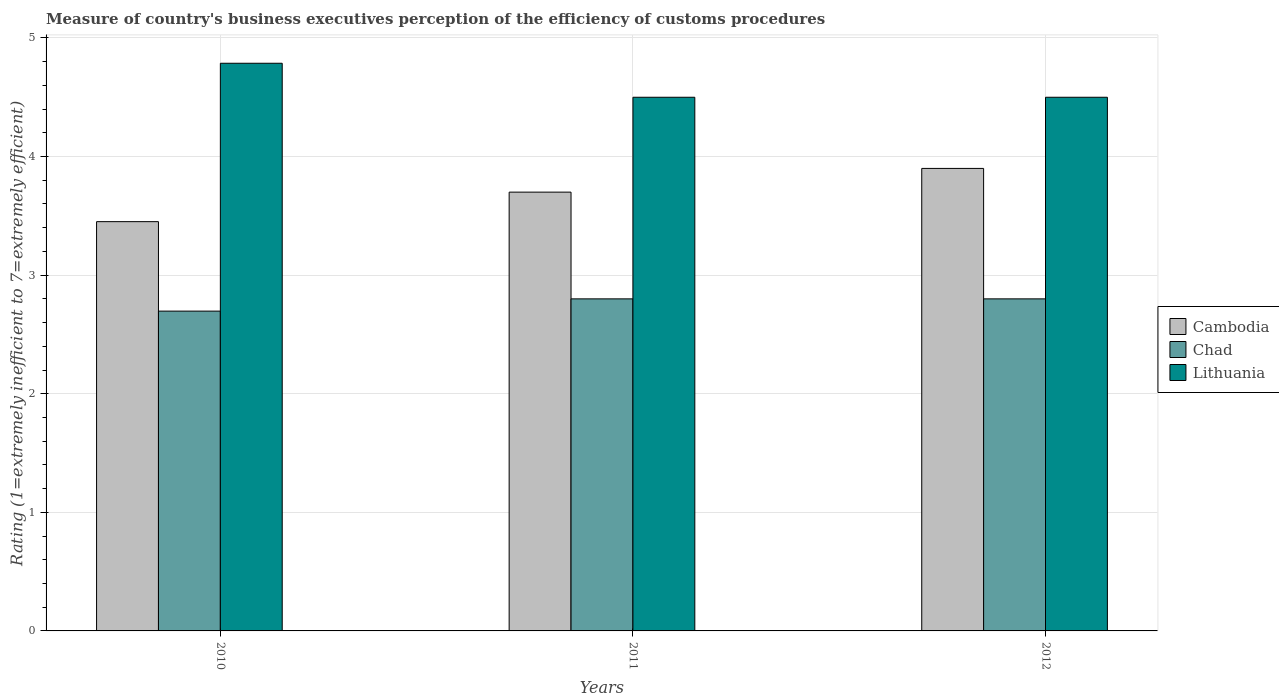How many groups of bars are there?
Offer a very short reply. 3. Are the number of bars per tick equal to the number of legend labels?
Offer a terse response. Yes. How many bars are there on the 3rd tick from the right?
Your response must be concise. 3. In how many cases, is the number of bars for a given year not equal to the number of legend labels?
Your answer should be compact. 0. What is the rating of the efficiency of customs procedure in Cambodia in 2010?
Offer a very short reply. 3.45. Across all years, what is the maximum rating of the efficiency of customs procedure in Chad?
Your response must be concise. 2.8. Across all years, what is the minimum rating of the efficiency of customs procedure in Chad?
Your answer should be compact. 2.7. In which year was the rating of the efficiency of customs procedure in Cambodia minimum?
Give a very brief answer. 2010. What is the total rating of the efficiency of customs procedure in Chad in the graph?
Provide a succinct answer. 8.3. What is the difference between the rating of the efficiency of customs procedure in Cambodia in 2010 and that in 2011?
Your answer should be compact. -0.25. What is the difference between the rating of the efficiency of customs procedure in Lithuania in 2011 and the rating of the efficiency of customs procedure in Chad in 2010?
Ensure brevity in your answer.  1.8. What is the average rating of the efficiency of customs procedure in Chad per year?
Your answer should be very brief. 2.77. In the year 2010, what is the difference between the rating of the efficiency of customs procedure in Cambodia and rating of the efficiency of customs procedure in Lithuania?
Provide a succinct answer. -1.34. What is the ratio of the rating of the efficiency of customs procedure in Cambodia in 2010 to that in 2011?
Provide a short and direct response. 0.93. What is the difference between the highest and the second highest rating of the efficiency of customs procedure in Lithuania?
Offer a terse response. 0.29. What is the difference between the highest and the lowest rating of the efficiency of customs procedure in Cambodia?
Keep it short and to the point. 0.45. In how many years, is the rating of the efficiency of customs procedure in Chad greater than the average rating of the efficiency of customs procedure in Chad taken over all years?
Your response must be concise. 2. What does the 3rd bar from the left in 2011 represents?
Your answer should be compact. Lithuania. What does the 1st bar from the right in 2010 represents?
Offer a terse response. Lithuania. What is the difference between two consecutive major ticks on the Y-axis?
Offer a terse response. 1. Are the values on the major ticks of Y-axis written in scientific E-notation?
Your answer should be compact. No. Where does the legend appear in the graph?
Offer a terse response. Center right. How many legend labels are there?
Ensure brevity in your answer.  3. How are the legend labels stacked?
Ensure brevity in your answer.  Vertical. What is the title of the graph?
Make the answer very short. Measure of country's business executives perception of the efficiency of customs procedures. What is the label or title of the Y-axis?
Provide a short and direct response. Rating (1=extremely inefficient to 7=extremely efficient). What is the Rating (1=extremely inefficient to 7=extremely efficient) in Cambodia in 2010?
Your response must be concise. 3.45. What is the Rating (1=extremely inefficient to 7=extremely efficient) in Chad in 2010?
Make the answer very short. 2.7. What is the Rating (1=extremely inefficient to 7=extremely efficient) of Lithuania in 2010?
Make the answer very short. 4.79. What is the Rating (1=extremely inefficient to 7=extremely efficient) in Cambodia in 2011?
Ensure brevity in your answer.  3.7. What is the Rating (1=extremely inefficient to 7=extremely efficient) in Chad in 2011?
Your answer should be very brief. 2.8. What is the Rating (1=extremely inefficient to 7=extremely efficient) of Lithuania in 2011?
Your response must be concise. 4.5. What is the Rating (1=extremely inefficient to 7=extremely efficient) in Lithuania in 2012?
Your response must be concise. 4.5. Across all years, what is the maximum Rating (1=extremely inefficient to 7=extremely efficient) of Chad?
Make the answer very short. 2.8. Across all years, what is the maximum Rating (1=extremely inefficient to 7=extremely efficient) in Lithuania?
Offer a very short reply. 4.79. Across all years, what is the minimum Rating (1=extremely inefficient to 7=extremely efficient) of Cambodia?
Offer a very short reply. 3.45. Across all years, what is the minimum Rating (1=extremely inefficient to 7=extremely efficient) in Chad?
Your answer should be very brief. 2.7. What is the total Rating (1=extremely inefficient to 7=extremely efficient) of Cambodia in the graph?
Ensure brevity in your answer.  11.05. What is the total Rating (1=extremely inefficient to 7=extremely efficient) in Chad in the graph?
Offer a terse response. 8.3. What is the total Rating (1=extremely inefficient to 7=extremely efficient) in Lithuania in the graph?
Offer a terse response. 13.79. What is the difference between the Rating (1=extremely inefficient to 7=extremely efficient) of Cambodia in 2010 and that in 2011?
Your answer should be very brief. -0.25. What is the difference between the Rating (1=extremely inefficient to 7=extremely efficient) in Chad in 2010 and that in 2011?
Offer a very short reply. -0.1. What is the difference between the Rating (1=extremely inefficient to 7=extremely efficient) of Lithuania in 2010 and that in 2011?
Provide a short and direct response. 0.29. What is the difference between the Rating (1=extremely inefficient to 7=extremely efficient) of Cambodia in 2010 and that in 2012?
Make the answer very short. -0.45. What is the difference between the Rating (1=extremely inefficient to 7=extremely efficient) of Chad in 2010 and that in 2012?
Your answer should be compact. -0.1. What is the difference between the Rating (1=extremely inefficient to 7=extremely efficient) of Lithuania in 2010 and that in 2012?
Your response must be concise. 0.29. What is the difference between the Rating (1=extremely inefficient to 7=extremely efficient) in Cambodia in 2011 and that in 2012?
Your answer should be very brief. -0.2. What is the difference between the Rating (1=extremely inefficient to 7=extremely efficient) in Chad in 2011 and that in 2012?
Offer a terse response. 0. What is the difference between the Rating (1=extremely inefficient to 7=extremely efficient) in Lithuania in 2011 and that in 2012?
Ensure brevity in your answer.  0. What is the difference between the Rating (1=extremely inefficient to 7=extremely efficient) in Cambodia in 2010 and the Rating (1=extremely inefficient to 7=extremely efficient) in Chad in 2011?
Provide a succinct answer. 0.65. What is the difference between the Rating (1=extremely inefficient to 7=extremely efficient) of Cambodia in 2010 and the Rating (1=extremely inefficient to 7=extremely efficient) of Lithuania in 2011?
Offer a terse response. -1.05. What is the difference between the Rating (1=extremely inefficient to 7=extremely efficient) of Chad in 2010 and the Rating (1=extremely inefficient to 7=extremely efficient) of Lithuania in 2011?
Your answer should be very brief. -1.8. What is the difference between the Rating (1=extremely inefficient to 7=extremely efficient) in Cambodia in 2010 and the Rating (1=extremely inefficient to 7=extremely efficient) in Chad in 2012?
Make the answer very short. 0.65. What is the difference between the Rating (1=extremely inefficient to 7=extremely efficient) in Cambodia in 2010 and the Rating (1=extremely inefficient to 7=extremely efficient) in Lithuania in 2012?
Offer a terse response. -1.05. What is the difference between the Rating (1=extremely inefficient to 7=extremely efficient) of Chad in 2010 and the Rating (1=extremely inefficient to 7=extremely efficient) of Lithuania in 2012?
Offer a very short reply. -1.8. What is the difference between the Rating (1=extremely inefficient to 7=extremely efficient) in Cambodia in 2011 and the Rating (1=extremely inefficient to 7=extremely efficient) in Chad in 2012?
Make the answer very short. 0.9. What is the difference between the Rating (1=extremely inefficient to 7=extremely efficient) in Cambodia in 2011 and the Rating (1=extremely inefficient to 7=extremely efficient) in Lithuania in 2012?
Ensure brevity in your answer.  -0.8. What is the average Rating (1=extremely inefficient to 7=extremely efficient) of Cambodia per year?
Your answer should be compact. 3.68. What is the average Rating (1=extremely inefficient to 7=extremely efficient) of Chad per year?
Provide a succinct answer. 2.77. What is the average Rating (1=extremely inefficient to 7=extremely efficient) in Lithuania per year?
Give a very brief answer. 4.6. In the year 2010, what is the difference between the Rating (1=extremely inefficient to 7=extremely efficient) of Cambodia and Rating (1=extremely inefficient to 7=extremely efficient) of Chad?
Provide a short and direct response. 0.75. In the year 2010, what is the difference between the Rating (1=extremely inefficient to 7=extremely efficient) of Cambodia and Rating (1=extremely inefficient to 7=extremely efficient) of Lithuania?
Make the answer very short. -1.34. In the year 2010, what is the difference between the Rating (1=extremely inefficient to 7=extremely efficient) in Chad and Rating (1=extremely inefficient to 7=extremely efficient) in Lithuania?
Offer a very short reply. -2.09. In the year 2011, what is the difference between the Rating (1=extremely inefficient to 7=extremely efficient) in Cambodia and Rating (1=extremely inefficient to 7=extremely efficient) in Chad?
Your answer should be compact. 0.9. In the year 2011, what is the difference between the Rating (1=extremely inefficient to 7=extremely efficient) in Chad and Rating (1=extremely inefficient to 7=extremely efficient) in Lithuania?
Keep it short and to the point. -1.7. In the year 2012, what is the difference between the Rating (1=extremely inefficient to 7=extremely efficient) of Chad and Rating (1=extremely inefficient to 7=extremely efficient) of Lithuania?
Your answer should be very brief. -1.7. What is the ratio of the Rating (1=extremely inefficient to 7=extremely efficient) of Cambodia in 2010 to that in 2011?
Offer a terse response. 0.93. What is the ratio of the Rating (1=extremely inefficient to 7=extremely efficient) of Chad in 2010 to that in 2011?
Make the answer very short. 0.96. What is the ratio of the Rating (1=extremely inefficient to 7=extremely efficient) in Lithuania in 2010 to that in 2011?
Give a very brief answer. 1.06. What is the ratio of the Rating (1=extremely inefficient to 7=extremely efficient) of Cambodia in 2010 to that in 2012?
Ensure brevity in your answer.  0.88. What is the ratio of the Rating (1=extremely inefficient to 7=extremely efficient) of Chad in 2010 to that in 2012?
Make the answer very short. 0.96. What is the ratio of the Rating (1=extremely inefficient to 7=extremely efficient) of Lithuania in 2010 to that in 2012?
Your answer should be very brief. 1.06. What is the ratio of the Rating (1=extremely inefficient to 7=extremely efficient) of Cambodia in 2011 to that in 2012?
Give a very brief answer. 0.95. What is the ratio of the Rating (1=extremely inefficient to 7=extremely efficient) in Chad in 2011 to that in 2012?
Give a very brief answer. 1. What is the difference between the highest and the second highest Rating (1=extremely inefficient to 7=extremely efficient) in Cambodia?
Your answer should be very brief. 0.2. What is the difference between the highest and the second highest Rating (1=extremely inefficient to 7=extremely efficient) in Lithuania?
Make the answer very short. 0.29. What is the difference between the highest and the lowest Rating (1=extremely inefficient to 7=extremely efficient) of Cambodia?
Your response must be concise. 0.45. What is the difference between the highest and the lowest Rating (1=extremely inefficient to 7=extremely efficient) in Chad?
Offer a terse response. 0.1. What is the difference between the highest and the lowest Rating (1=extremely inefficient to 7=extremely efficient) in Lithuania?
Your answer should be compact. 0.29. 